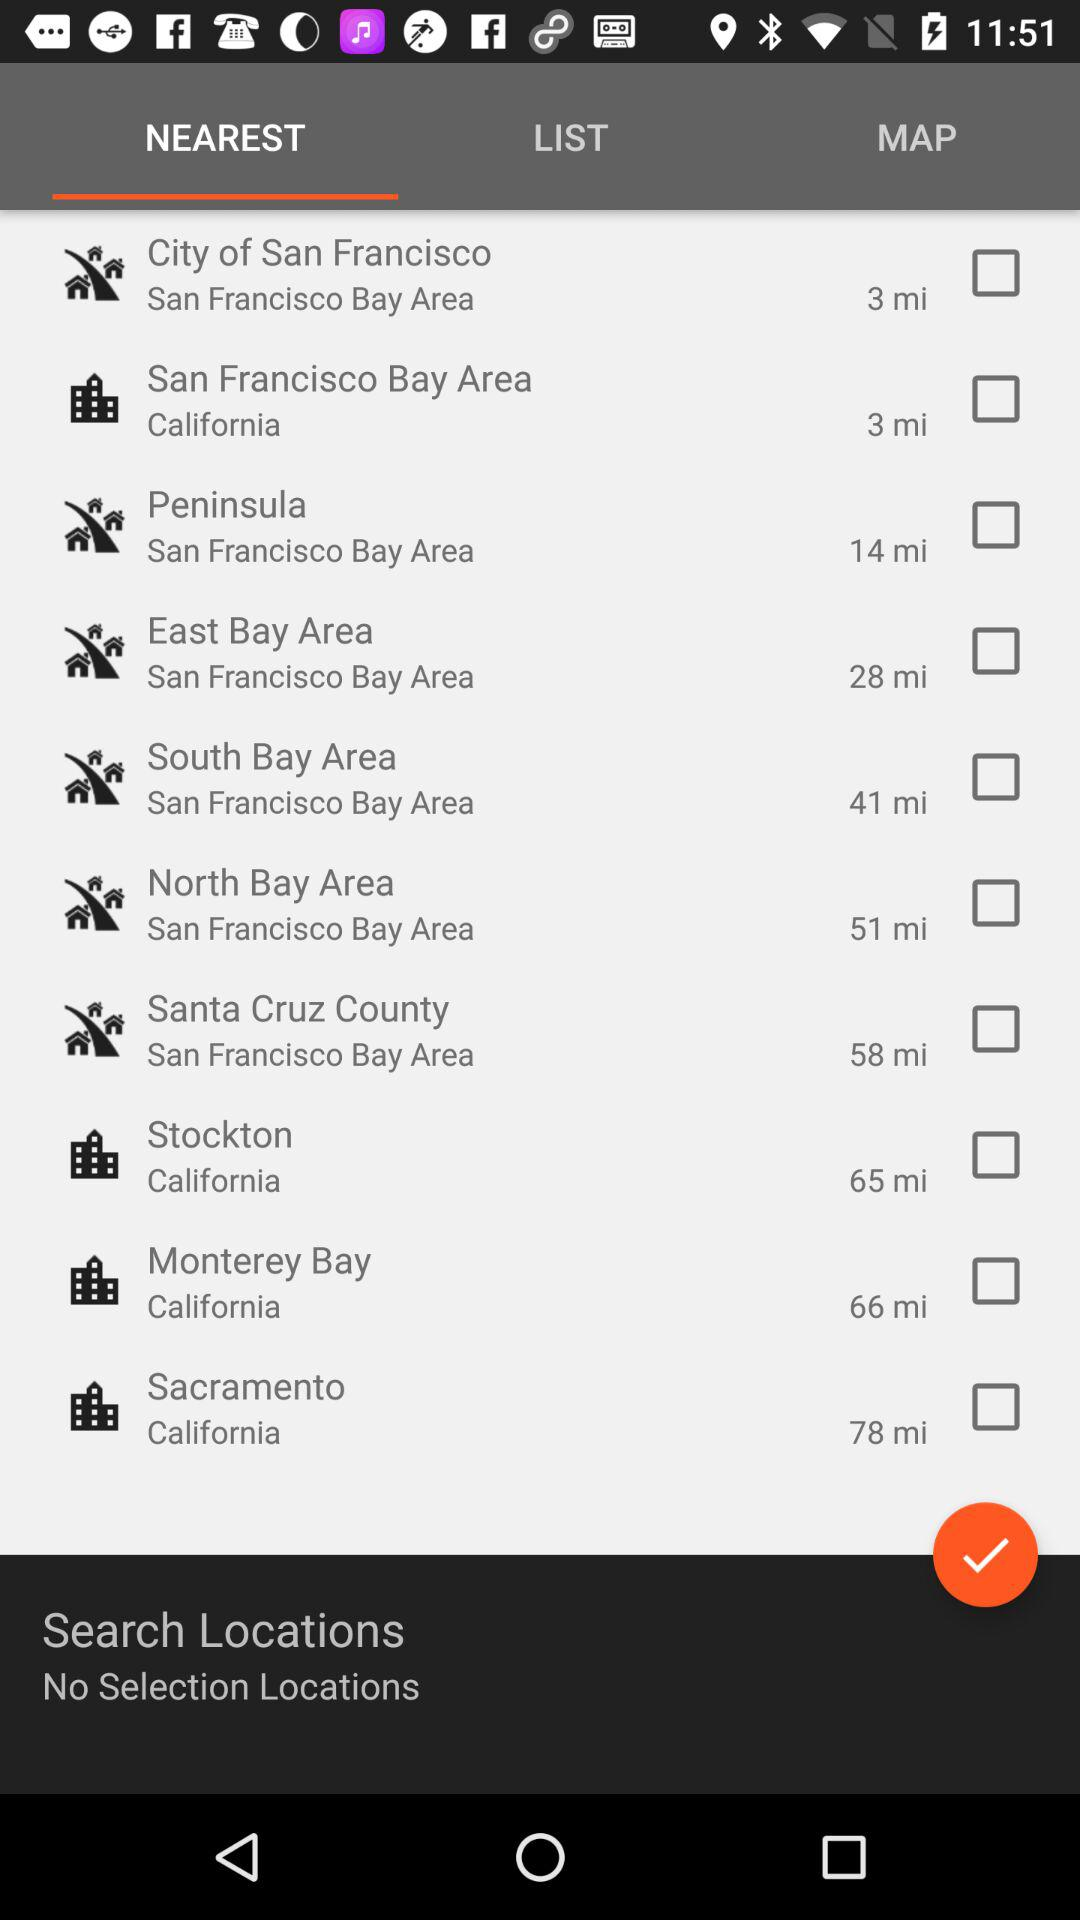What is the distance to South Bay Area? The distance to South Bay Area is 41 miles. 